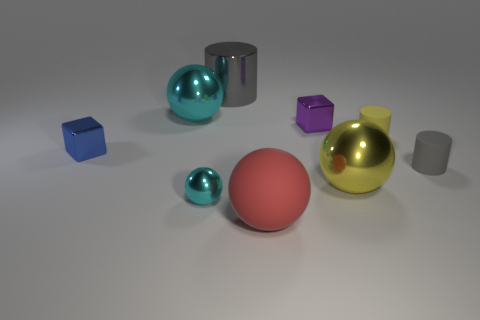Subtract all yellow spheres. How many spheres are left? 3 Subtract all metallic spheres. How many spheres are left? 1 Add 6 metallic cylinders. How many metallic cylinders are left? 7 Add 6 tiny purple shiny cubes. How many tiny purple shiny cubes exist? 7 Subtract 0 red cylinders. How many objects are left? 9 Subtract all blocks. How many objects are left? 7 Subtract all green balls. Subtract all green cubes. How many balls are left? 4 Subtract all small cyan cylinders. Subtract all small matte objects. How many objects are left? 7 